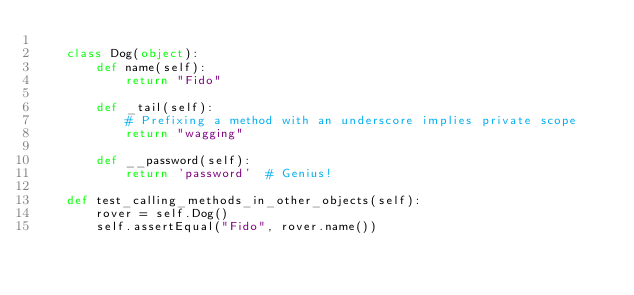Convert code to text. <code><loc_0><loc_0><loc_500><loc_500><_Python_>
    class Dog(object):
        def name(self):
            return "Fido"

        def _tail(self):
            # Prefixing a method with an underscore implies private scope
            return "wagging"

        def __password(self):
            return 'password'  # Genius!

    def test_calling_methods_in_other_objects(self):
        rover = self.Dog()
        self.assertEqual("Fido", rover.name())
</code> 